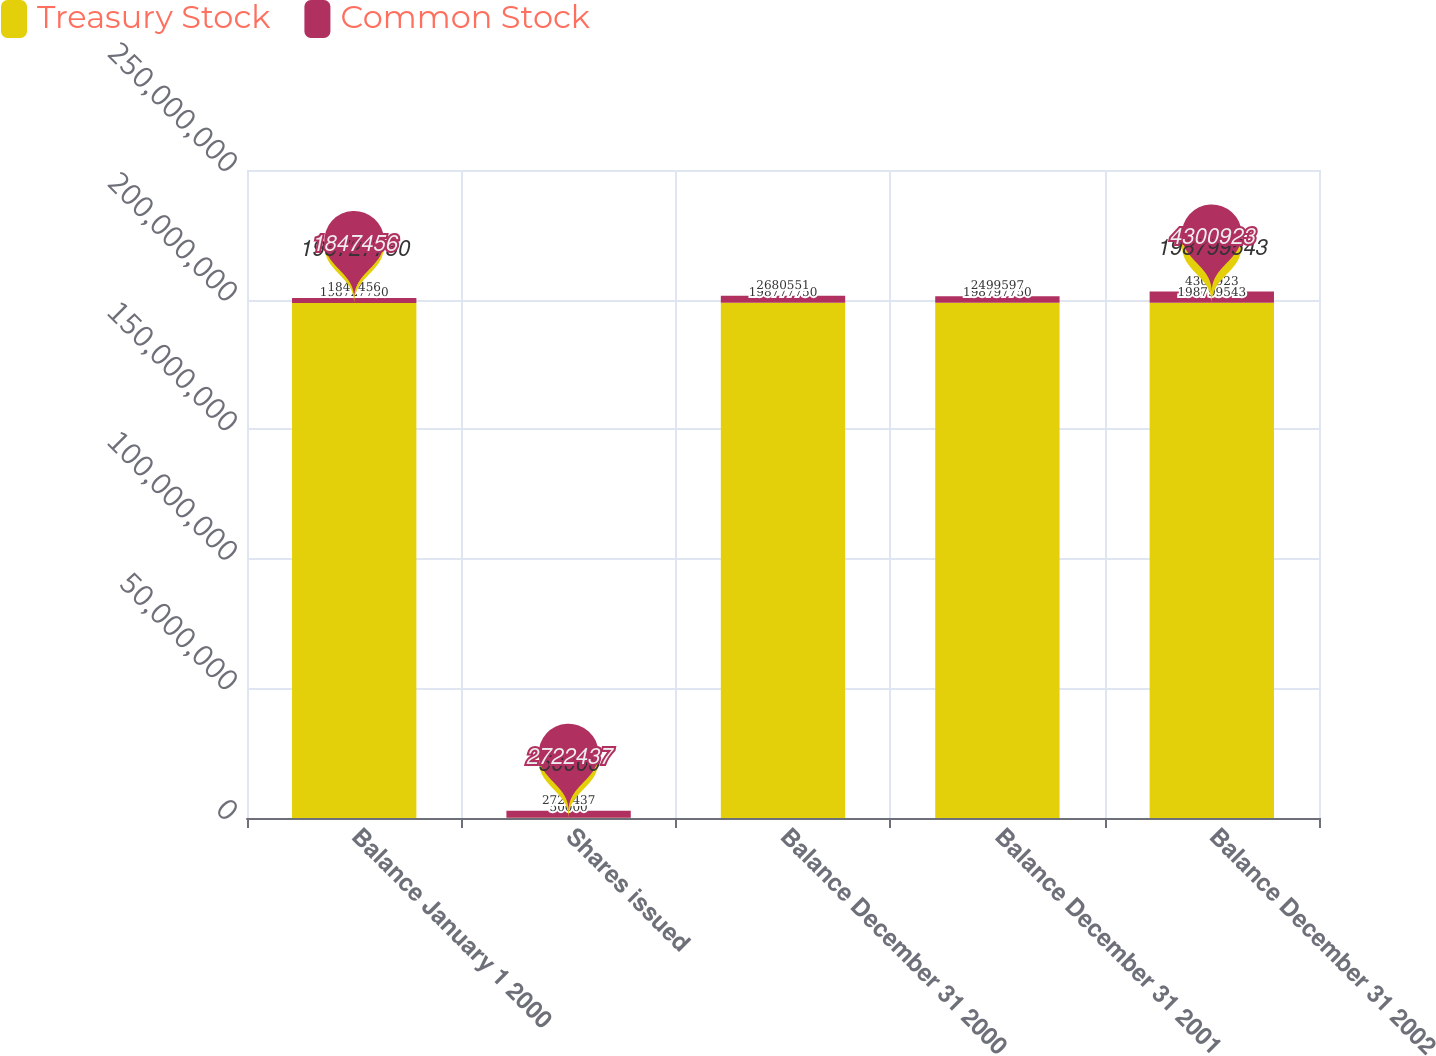Convert chart to OTSL. <chart><loc_0><loc_0><loc_500><loc_500><stacked_bar_chart><ecel><fcel>Balance January 1 2000<fcel>Shares issued<fcel>Balance December 31 2000<fcel>Balance December 31 2001<fcel>Balance December 31 2002<nl><fcel>Treasury Stock<fcel>1.98728e+08<fcel>50000<fcel>1.98778e+08<fcel>1.98798e+08<fcel>1.988e+08<nl><fcel>Common Stock<fcel>1.84746e+06<fcel>2.72244e+06<fcel>2.68055e+06<fcel>2.4996e+06<fcel>4.30092e+06<nl></chart> 